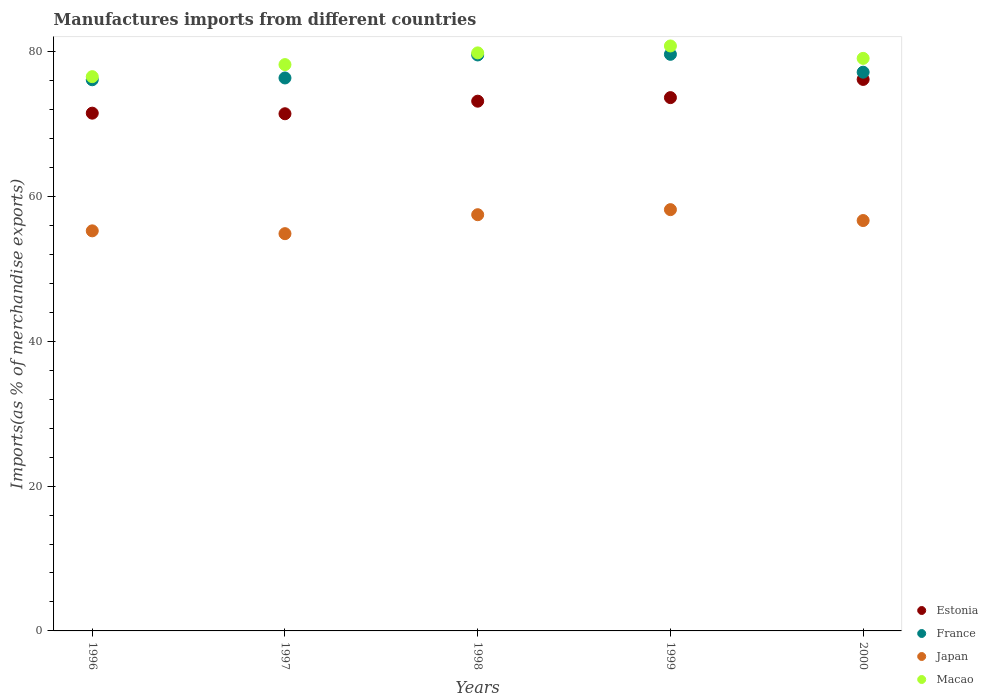Is the number of dotlines equal to the number of legend labels?
Provide a short and direct response. Yes. What is the percentage of imports to different countries in Macao in 1998?
Ensure brevity in your answer.  79.84. Across all years, what is the maximum percentage of imports to different countries in Japan?
Make the answer very short. 58.18. Across all years, what is the minimum percentage of imports to different countries in France?
Your response must be concise. 76.12. What is the total percentage of imports to different countries in Macao in the graph?
Provide a succinct answer. 394.47. What is the difference between the percentage of imports to different countries in France in 1996 and that in 2000?
Provide a short and direct response. -1.05. What is the difference between the percentage of imports to different countries in Japan in 1997 and the percentage of imports to different countries in Estonia in 1996?
Ensure brevity in your answer.  -16.64. What is the average percentage of imports to different countries in Macao per year?
Offer a very short reply. 78.89. In the year 1996, what is the difference between the percentage of imports to different countries in Macao and percentage of imports to different countries in France?
Ensure brevity in your answer.  0.43. What is the ratio of the percentage of imports to different countries in Japan in 1998 to that in 2000?
Make the answer very short. 1.01. What is the difference between the highest and the second highest percentage of imports to different countries in France?
Make the answer very short. 0.09. What is the difference between the highest and the lowest percentage of imports to different countries in Japan?
Your answer should be compact. 3.32. Is it the case that in every year, the sum of the percentage of imports to different countries in Japan and percentage of imports to different countries in Estonia  is greater than the sum of percentage of imports to different countries in France and percentage of imports to different countries in Macao?
Ensure brevity in your answer.  No. Does the percentage of imports to different countries in Japan monotonically increase over the years?
Provide a succinct answer. No. Is the percentage of imports to different countries in France strictly less than the percentage of imports to different countries in Estonia over the years?
Give a very brief answer. No. How many years are there in the graph?
Make the answer very short. 5. What is the difference between two consecutive major ticks on the Y-axis?
Make the answer very short. 20. Where does the legend appear in the graph?
Provide a succinct answer. Bottom right. How are the legend labels stacked?
Your answer should be compact. Vertical. What is the title of the graph?
Ensure brevity in your answer.  Manufactures imports from different countries. What is the label or title of the X-axis?
Give a very brief answer. Years. What is the label or title of the Y-axis?
Offer a very short reply. Imports(as % of merchandise exports). What is the Imports(as % of merchandise exports) in Estonia in 1996?
Give a very brief answer. 71.51. What is the Imports(as % of merchandise exports) of France in 1996?
Give a very brief answer. 76.12. What is the Imports(as % of merchandise exports) in Japan in 1996?
Keep it short and to the point. 55.26. What is the Imports(as % of merchandise exports) of Macao in 1996?
Keep it short and to the point. 76.55. What is the Imports(as % of merchandise exports) in Estonia in 1997?
Your response must be concise. 71.43. What is the Imports(as % of merchandise exports) in France in 1997?
Ensure brevity in your answer.  76.37. What is the Imports(as % of merchandise exports) in Japan in 1997?
Provide a short and direct response. 54.87. What is the Imports(as % of merchandise exports) of Macao in 1997?
Offer a very short reply. 78.22. What is the Imports(as % of merchandise exports) of Estonia in 1998?
Provide a short and direct response. 73.16. What is the Imports(as % of merchandise exports) of France in 1998?
Your response must be concise. 79.55. What is the Imports(as % of merchandise exports) in Japan in 1998?
Your answer should be very brief. 57.48. What is the Imports(as % of merchandise exports) of Macao in 1998?
Your answer should be compact. 79.84. What is the Imports(as % of merchandise exports) in Estonia in 1999?
Keep it short and to the point. 73.66. What is the Imports(as % of merchandise exports) in France in 1999?
Your answer should be compact. 79.64. What is the Imports(as % of merchandise exports) of Japan in 1999?
Make the answer very short. 58.18. What is the Imports(as % of merchandise exports) in Macao in 1999?
Provide a short and direct response. 80.79. What is the Imports(as % of merchandise exports) of Estonia in 2000?
Your answer should be very brief. 76.17. What is the Imports(as % of merchandise exports) of France in 2000?
Offer a terse response. 77.17. What is the Imports(as % of merchandise exports) in Japan in 2000?
Your response must be concise. 56.68. What is the Imports(as % of merchandise exports) in Macao in 2000?
Your answer should be compact. 79.08. Across all years, what is the maximum Imports(as % of merchandise exports) in Estonia?
Offer a very short reply. 76.17. Across all years, what is the maximum Imports(as % of merchandise exports) in France?
Keep it short and to the point. 79.64. Across all years, what is the maximum Imports(as % of merchandise exports) in Japan?
Your answer should be compact. 58.18. Across all years, what is the maximum Imports(as % of merchandise exports) in Macao?
Make the answer very short. 80.79. Across all years, what is the minimum Imports(as % of merchandise exports) in Estonia?
Your response must be concise. 71.43. Across all years, what is the minimum Imports(as % of merchandise exports) in France?
Keep it short and to the point. 76.12. Across all years, what is the minimum Imports(as % of merchandise exports) of Japan?
Make the answer very short. 54.87. Across all years, what is the minimum Imports(as % of merchandise exports) in Macao?
Your answer should be compact. 76.55. What is the total Imports(as % of merchandise exports) in Estonia in the graph?
Your answer should be compact. 365.93. What is the total Imports(as % of merchandise exports) of France in the graph?
Give a very brief answer. 388.85. What is the total Imports(as % of merchandise exports) in Japan in the graph?
Provide a short and direct response. 282.47. What is the total Imports(as % of merchandise exports) of Macao in the graph?
Provide a succinct answer. 394.47. What is the difference between the Imports(as % of merchandise exports) in Estonia in 1996 and that in 1997?
Provide a succinct answer. 0.08. What is the difference between the Imports(as % of merchandise exports) in France in 1996 and that in 1997?
Make the answer very short. -0.25. What is the difference between the Imports(as % of merchandise exports) in Japan in 1996 and that in 1997?
Give a very brief answer. 0.39. What is the difference between the Imports(as % of merchandise exports) of Macao in 1996 and that in 1997?
Your answer should be compact. -1.66. What is the difference between the Imports(as % of merchandise exports) of Estonia in 1996 and that in 1998?
Ensure brevity in your answer.  -1.66. What is the difference between the Imports(as % of merchandise exports) of France in 1996 and that in 1998?
Your response must be concise. -3.43. What is the difference between the Imports(as % of merchandise exports) in Japan in 1996 and that in 1998?
Ensure brevity in your answer.  -2.23. What is the difference between the Imports(as % of merchandise exports) of Macao in 1996 and that in 1998?
Give a very brief answer. -3.28. What is the difference between the Imports(as % of merchandise exports) in Estonia in 1996 and that in 1999?
Your answer should be very brief. -2.15. What is the difference between the Imports(as % of merchandise exports) in France in 1996 and that in 1999?
Offer a very short reply. -3.51. What is the difference between the Imports(as % of merchandise exports) in Japan in 1996 and that in 1999?
Offer a very short reply. -2.93. What is the difference between the Imports(as % of merchandise exports) in Macao in 1996 and that in 1999?
Give a very brief answer. -4.24. What is the difference between the Imports(as % of merchandise exports) of Estonia in 1996 and that in 2000?
Your answer should be very brief. -4.66. What is the difference between the Imports(as % of merchandise exports) of France in 1996 and that in 2000?
Your answer should be compact. -1.05. What is the difference between the Imports(as % of merchandise exports) of Japan in 1996 and that in 2000?
Keep it short and to the point. -1.42. What is the difference between the Imports(as % of merchandise exports) in Macao in 1996 and that in 2000?
Offer a terse response. -2.53. What is the difference between the Imports(as % of merchandise exports) of Estonia in 1997 and that in 1998?
Your response must be concise. -1.74. What is the difference between the Imports(as % of merchandise exports) in France in 1997 and that in 1998?
Provide a succinct answer. -3.18. What is the difference between the Imports(as % of merchandise exports) of Japan in 1997 and that in 1998?
Offer a very short reply. -2.62. What is the difference between the Imports(as % of merchandise exports) of Macao in 1997 and that in 1998?
Provide a short and direct response. -1.62. What is the difference between the Imports(as % of merchandise exports) of Estonia in 1997 and that in 1999?
Offer a very short reply. -2.23. What is the difference between the Imports(as % of merchandise exports) in France in 1997 and that in 1999?
Give a very brief answer. -3.27. What is the difference between the Imports(as % of merchandise exports) in Japan in 1997 and that in 1999?
Keep it short and to the point. -3.32. What is the difference between the Imports(as % of merchandise exports) of Macao in 1997 and that in 1999?
Your answer should be very brief. -2.58. What is the difference between the Imports(as % of merchandise exports) in Estonia in 1997 and that in 2000?
Offer a terse response. -4.74. What is the difference between the Imports(as % of merchandise exports) of France in 1997 and that in 2000?
Provide a succinct answer. -0.8. What is the difference between the Imports(as % of merchandise exports) of Japan in 1997 and that in 2000?
Your response must be concise. -1.81. What is the difference between the Imports(as % of merchandise exports) in Macao in 1997 and that in 2000?
Make the answer very short. -0.86. What is the difference between the Imports(as % of merchandise exports) in Estonia in 1998 and that in 1999?
Your answer should be compact. -0.49. What is the difference between the Imports(as % of merchandise exports) in France in 1998 and that in 1999?
Make the answer very short. -0.09. What is the difference between the Imports(as % of merchandise exports) of Japan in 1998 and that in 1999?
Offer a very short reply. -0.7. What is the difference between the Imports(as % of merchandise exports) in Macao in 1998 and that in 1999?
Your answer should be very brief. -0.96. What is the difference between the Imports(as % of merchandise exports) of Estonia in 1998 and that in 2000?
Your response must be concise. -3. What is the difference between the Imports(as % of merchandise exports) of France in 1998 and that in 2000?
Ensure brevity in your answer.  2.38. What is the difference between the Imports(as % of merchandise exports) of Japan in 1998 and that in 2000?
Make the answer very short. 0.8. What is the difference between the Imports(as % of merchandise exports) in Macao in 1998 and that in 2000?
Ensure brevity in your answer.  0.76. What is the difference between the Imports(as % of merchandise exports) in Estonia in 1999 and that in 2000?
Give a very brief answer. -2.51. What is the difference between the Imports(as % of merchandise exports) of France in 1999 and that in 2000?
Your response must be concise. 2.47. What is the difference between the Imports(as % of merchandise exports) of Japan in 1999 and that in 2000?
Offer a terse response. 1.5. What is the difference between the Imports(as % of merchandise exports) of Macao in 1999 and that in 2000?
Keep it short and to the point. 1.71. What is the difference between the Imports(as % of merchandise exports) in Estonia in 1996 and the Imports(as % of merchandise exports) in France in 1997?
Ensure brevity in your answer.  -4.86. What is the difference between the Imports(as % of merchandise exports) in Estonia in 1996 and the Imports(as % of merchandise exports) in Japan in 1997?
Your response must be concise. 16.64. What is the difference between the Imports(as % of merchandise exports) in Estonia in 1996 and the Imports(as % of merchandise exports) in Macao in 1997?
Keep it short and to the point. -6.71. What is the difference between the Imports(as % of merchandise exports) of France in 1996 and the Imports(as % of merchandise exports) of Japan in 1997?
Offer a very short reply. 21.26. What is the difference between the Imports(as % of merchandise exports) in France in 1996 and the Imports(as % of merchandise exports) in Macao in 1997?
Ensure brevity in your answer.  -2.09. What is the difference between the Imports(as % of merchandise exports) of Japan in 1996 and the Imports(as % of merchandise exports) of Macao in 1997?
Keep it short and to the point. -22.96. What is the difference between the Imports(as % of merchandise exports) in Estonia in 1996 and the Imports(as % of merchandise exports) in France in 1998?
Offer a terse response. -8.04. What is the difference between the Imports(as % of merchandise exports) in Estonia in 1996 and the Imports(as % of merchandise exports) in Japan in 1998?
Give a very brief answer. 14.02. What is the difference between the Imports(as % of merchandise exports) in Estonia in 1996 and the Imports(as % of merchandise exports) in Macao in 1998?
Give a very brief answer. -8.33. What is the difference between the Imports(as % of merchandise exports) in France in 1996 and the Imports(as % of merchandise exports) in Japan in 1998?
Keep it short and to the point. 18.64. What is the difference between the Imports(as % of merchandise exports) of France in 1996 and the Imports(as % of merchandise exports) of Macao in 1998?
Provide a succinct answer. -3.71. What is the difference between the Imports(as % of merchandise exports) of Japan in 1996 and the Imports(as % of merchandise exports) of Macao in 1998?
Offer a terse response. -24.58. What is the difference between the Imports(as % of merchandise exports) in Estonia in 1996 and the Imports(as % of merchandise exports) in France in 1999?
Keep it short and to the point. -8.13. What is the difference between the Imports(as % of merchandise exports) in Estonia in 1996 and the Imports(as % of merchandise exports) in Japan in 1999?
Your answer should be compact. 13.33. What is the difference between the Imports(as % of merchandise exports) in Estonia in 1996 and the Imports(as % of merchandise exports) in Macao in 1999?
Make the answer very short. -9.28. What is the difference between the Imports(as % of merchandise exports) of France in 1996 and the Imports(as % of merchandise exports) of Japan in 1999?
Provide a succinct answer. 17.94. What is the difference between the Imports(as % of merchandise exports) of France in 1996 and the Imports(as % of merchandise exports) of Macao in 1999?
Keep it short and to the point. -4.67. What is the difference between the Imports(as % of merchandise exports) of Japan in 1996 and the Imports(as % of merchandise exports) of Macao in 1999?
Your response must be concise. -25.54. What is the difference between the Imports(as % of merchandise exports) in Estonia in 1996 and the Imports(as % of merchandise exports) in France in 2000?
Make the answer very short. -5.66. What is the difference between the Imports(as % of merchandise exports) in Estonia in 1996 and the Imports(as % of merchandise exports) in Japan in 2000?
Provide a succinct answer. 14.83. What is the difference between the Imports(as % of merchandise exports) of Estonia in 1996 and the Imports(as % of merchandise exports) of Macao in 2000?
Your answer should be compact. -7.57. What is the difference between the Imports(as % of merchandise exports) in France in 1996 and the Imports(as % of merchandise exports) in Japan in 2000?
Offer a terse response. 19.44. What is the difference between the Imports(as % of merchandise exports) of France in 1996 and the Imports(as % of merchandise exports) of Macao in 2000?
Make the answer very short. -2.95. What is the difference between the Imports(as % of merchandise exports) of Japan in 1996 and the Imports(as % of merchandise exports) of Macao in 2000?
Your answer should be compact. -23.82. What is the difference between the Imports(as % of merchandise exports) of Estonia in 1997 and the Imports(as % of merchandise exports) of France in 1998?
Ensure brevity in your answer.  -8.12. What is the difference between the Imports(as % of merchandise exports) of Estonia in 1997 and the Imports(as % of merchandise exports) of Japan in 1998?
Provide a succinct answer. 13.94. What is the difference between the Imports(as % of merchandise exports) of Estonia in 1997 and the Imports(as % of merchandise exports) of Macao in 1998?
Offer a terse response. -8.41. What is the difference between the Imports(as % of merchandise exports) in France in 1997 and the Imports(as % of merchandise exports) in Japan in 1998?
Keep it short and to the point. 18.89. What is the difference between the Imports(as % of merchandise exports) of France in 1997 and the Imports(as % of merchandise exports) of Macao in 1998?
Your answer should be very brief. -3.47. What is the difference between the Imports(as % of merchandise exports) of Japan in 1997 and the Imports(as % of merchandise exports) of Macao in 1998?
Make the answer very short. -24.97. What is the difference between the Imports(as % of merchandise exports) of Estonia in 1997 and the Imports(as % of merchandise exports) of France in 1999?
Provide a succinct answer. -8.21. What is the difference between the Imports(as % of merchandise exports) of Estonia in 1997 and the Imports(as % of merchandise exports) of Japan in 1999?
Make the answer very short. 13.24. What is the difference between the Imports(as % of merchandise exports) of Estonia in 1997 and the Imports(as % of merchandise exports) of Macao in 1999?
Provide a short and direct response. -9.36. What is the difference between the Imports(as % of merchandise exports) in France in 1997 and the Imports(as % of merchandise exports) in Japan in 1999?
Your answer should be very brief. 18.19. What is the difference between the Imports(as % of merchandise exports) in France in 1997 and the Imports(as % of merchandise exports) in Macao in 1999?
Give a very brief answer. -4.42. What is the difference between the Imports(as % of merchandise exports) in Japan in 1997 and the Imports(as % of merchandise exports) in Macao in 1999?
Your answer should be compact. -25.92. What is the difference between the Imports(as % of merchandise exports) of Estonia in 1997 and the Imports(as % of merchandise exports) of France in 2000?
Give a very brief answer. -5.74. What is the difference between the Imports(as % of merchandise exports) in Estonia in 1997 and the Imports(as % of merchandise exports) in Japan in 2000?
Give a very brief answer. 14.75. What is the difference between the Imports(as % of merchandise exports) of Estonia in 1997 and the Imports(as % of merchandise exports) of Macao in 2000?
Make the answer very short. -7.65. What is the difference between the Imports(as % of merchandise exports) of France in 1997 and the Imports(as % of merchandise exports) of Japan in 2000?
Ensure brevity in your answer.  19.69. What is the difference between the Imports(as % of merchandise exports) of France in 1997 and the Imports(as % of merchandise exports) of Macao in 2000?
Ensure brevity in your answer.  -2.71. What is the difference between the Imports(as % of merchandise exports) of Japan in 1997 and the Imports(as % of merchandise exports) of Macao in 2000?
Give a very brief answer. -24.21. What is the difference between the Imports(as % of merchandise exports) of Estonia in 1998 and the Imports(as % of merchandise exports) of France in 1999?
Your response must be concise. -6.47. What is the difference between the Imports(as % of merchandise exports) of Estonia in 1998 and the Imports(as % of merchandise exports) of Japan in 1999?
Provide a short and direct response. 14.98. What is the difference between the Imports(as % of merchandise exports) in Estonia in 1998 and the Imports(as % of merchandise exports) in Macao in 1999?
Offer a terse response. -7.63. What is the difference between the Imports(as % of merchandise exports) of France in 1998 and the Imports(as % of merchandise exports) of Japan in 1999?
Offer a very short reply. 21.36. What is the difference between the Imports(as % of merchandise exports) in France in 1998 and the Imports(as % of merchandise exports) in Macao in 1999?
Provide a succinct answer. -1.24. What is the difference between the Imports(as % of merchandise exports) of Japan in 1998 and the Imports(as % of merchandise exports) of Macao in 1999?
Ensure brevity in your answer.  -23.31. What is the difference between the Imports(as % of merchandise exports) of Estonia in 1998 and the Imports(as % of merchandise exports) of France in 2000?
Offer a very short reply. -4. What is the difference between the Imports(as % of merchandise exports) of Estonia in 1998 and the Imports(as % of merchandise exports) of Japan in 2000?
Keep it short and to the point. 16.49. What is the difference between the Imports(as % of merchandise exports) in Estonia in 1998 and the Imports(as % of merchandise exports) in Macao in 2000?
Make the answer very short. -5.91. What is the difference between the Imports(as % of merchandise exports) in France in 1998 and the Imports(as % of merchandise exports) in Japan in 2000?
Offer a terse response. 22.87. What is the difference between the Imports(as % of merchandise exports) of France in 1998 and the Imports(as % of merchandise exports) of Macao in 2000?
Your answer should be very brief. 0.47. What is the difference between the Imports(as % of merchandise exports) in Japan in 1998 and the Imports(as % of merchandise exports) in Macao in 2000?
Your response must be concise. -21.59. What is the difference between the Imports(as % of merchandise exports) of Estonia in 1999 and the Imports(as % of merchandise exports) of France in 2000?
Keep it short and to the point. -3.51. What is the difference between the Imports(as % of merchandise exports) in Estonia in 1999 and the Imports(as % of merchandise exports) in Japan in 2000?
Provide a short and direct response. 16.98. What is the difference between the Imports(as % of merchandise exports) in Estonia in 1999 and the Imports(as % of merchandise exports) in Macao in 2000?
Your response must be concise. -5.42. What is the difference between the Imports(as % of merchandise exports) of France in 1999 and the Imports(as % of merchandise exports) of Japan in 2000?
Offer a terse response. 22.96. What is the difference between the Imports(as % of merchandise exports) in France in 1999 and the Imports(as % of merchandise exports) in Macao in 2000?
Offer a very short reply. 0.56. What is the difference between the Imports(as % of merchandise exports) in Japan in 1999 and the Imports(as % of merchandise exports) in Macao in 2000?
Offer a very short reply. -20.89. What is the average Imports(as % of merchandise exports) of Estonia per year?
Your answer should be very brief. 73.19. What is the average Imports(as % of merchandise exports) of France per year?
Make the answer very short. 77.77. What is the average Imports(as % of merchandise exports) of Japan per year?
Ensure brevity in your answer.  56.49. What is the average Imports(as % of merchandise exports) in Macao per year?
Your answer should be very brief. 78.89. In the year 1996, what is the difference between the Imports(as % of merchandise exports) of Estonia and Imports(as % of merchandise exports) of France?
Ensure brevity in your answer.  -4.61. In the year 1996, what is the difference between the Imports(as % of merchandise exports) of Estonia and Imports(as % of merchandise exports) of Japan?
Ensure brevity in your answer.  16.25. In the year 1996, what is the difference between the Imports(as % of merchandise exports) of Estonia and Imports(as % of merchandise exports) of Macao?
Your answer should be compact. -5.04. In the year 1996, what is the difference between the Imports(as % of merchandise exports) of France and Imports(as % of merchandise exports) of Japan?
Provide a succinct answer. 20.87. In the year 1996, what is the difference between the Imports(as % of merchandise exports) in France and Imports(as % of merchandise exports) in Macao?
Offer a terse response. -0.43. In the year 1996, what is the difference between the Imports(as % of merchandise exports) of Japan and Imports(as % of merchandise exports) of Macao?
Your answer should be very brief. -21.3. In the year 1997, what is the difference between the Imports(as % of merchandise exports) of Estonia and Imports(as % of merchandise exports) of France?
Provide a succinct answer. -4.94. In the year 1997, what is the difference between the Imports(as % of merchandise exports) in Estonia and Imports(as % of merchandise exports) in Japan?
Your answer should be compact. 16.56. In the year 1997, what is the difference between the Imports(as % of merchandise exports) of Estonia and Imports(as % of merchandise exports) of Macao?
Your response must be concise. -6.79. In the year 1997, what is the difference between the Imports(as % of merchandise exports) of France and Imports(as % of merchandise exports) of Japan?
Your answer should be very brief. 21.5. In the year 1997, what is the difference between the Imports(as % of merchandise exports) in France and Imports(as % of merchandise exports) in Macao?
Your answer should be compact. -1.85. In the year 1997, what is the difference between the Imports(as % of merchandise exports) of Japan and Imports(as % of merchandise exports) of Macao?
Ensure brevity in your answer.  -23.35. In the year 1998, what is the difference between the Imports(as % of merchandise exports) in Estonia and Imports(as % of merchandise exports) in France?
Your answer should be very brief. -6.38. In the year 1998, what is the difference between the Imports(as % of merchandise exports) in Estonia and Imports(as % of merchandise exports) in Japan?
Keep it short and to the point. 15.68. In the year 1998, what is the difference between the Imports(as % of merchandise exports) of Estonia and Imports(as % of merchandise exports) of Macao?
Ensure brevity in your answer.  -6.67. In the year 1998, what is the difference between the Imports(as % of merchandise exports) of France and Imports(as % of merchandise exports) of Japan?
Your answer should be very brief. 22.06. In the year 1998, what is the difference between the Imports(as % of merchandise exports) in France and Imports(as % of merchandise exports) in Macao?
Your answer should be very brief. -0.29. In the year 1998, what is the difference between the Imports(as % of merchandise exports) of Japan and Imports(as % of merchandise exports) of Macao?
Offer a terse response. -22.35. In the year 1999, what is the difference between the Imports(as % of merchandise exports) of Estonia and Imports(as % of merchandise exports) of France?
Make the answer very short. -5.98. In the year 1999, what is the difference between the Imports(as % of merchandise exports) of Estonia and Imports(as % of merchandise exports) of Japan?
Keep it short and to the point. 15.47. In the year 1999, what is the difference between the Imports(as % of merchandise exports) in Estonia and Imports(as % of merchandise exports) in Macao?
Offer a terse response. -7.14. In the year 1999, what is the difference between the Imports(as % of merchandise exports) in France and Imports(as % of merchandise exports) in Japan?
Your answer should be very brief. 21.45. In the year 1999, what is the difference between the Imports(as % of merchandise exports) in France and Imports(as % of merchandise exports) in Macao?
Your answer should be very brief. -1.15. In the year 1999, what is the difference between the Imports(as % of merchandise exports) of Japan and Imports(as % of merchandise exports) of Macao?
Your answer should be very brief. -22.61. In the year 2000, what is the difference between the Imports(as % of merchandise exports) in Estonia and Imports(as % of merchandise exports) in France?
Ensure brevity in your answer.  -1. In the year 2000, what is the difference between the Imports(as % of merchandise exports) in Estonia and Imports(as % of merchandise exports) in Japan?
Your answer should be compact. 19.49. In the year 2000, what is the difference between the Imports(as % of merchandise exports) in Estonia and Imports(as % of merchandise exports) in Macao?
Your answer should be very brief. -2.91. In the year 2000, what is the difference between the Imports(as % of merchandise exports) of France and Imports(as % of merchandise exports) of Japan?
Make the answer very short. 20.49. In the year 2000, what is the difference between the Imports(as % of merchandise exports) in France and Imports(as % of merchandise exports) in Macao?
Your answer should be compact. -1.91. In the year 2000, what is the difference between the Imports(as % of merchandise exports) in Japan and Imports(as % of merchandise exports) in Macao?
Your answer should be very brief. -22.4. What is the ratio of the Imports(as % of merchandise exports) in France in 1996 to that in 1997?
Give a very brief answer. 1. What is the ratio of the Imports(as % of merchandise exports) in Japan in 1996 to that in 1997?
Your response must be concise. 1.01. What is the ratio of the Imports(as % of merchandise exports) of Macao in 1996 to that in 1997?
Provide a succinct answer. 0.98. What is the ratio of the Imports(as % of merchandise exports) of Estonia in 1996 to that in 1998?
Offer a very short reply. 0.98. What is the ratio of the Imports(as % of merchandise exports) of France in 1996 to that in 1998?
Provide a succinct answer. 0.96. What is the ratio of the Imports(as % of merchandise exports) of Japan in 1996 to that in 1998?
Your answer should be very brief. 0.96. What is the ratio of the Imports(as % of merchandise exports) of Macao in 1996 to that in 1998?
Your answer should be compact. 0.96. What is the ratio of the Imports(as % of merchandise exports) of Estonia in 1996 to that in 1999?
Your answer should be compact. 0.97. What is the ratio of the Imports(as % of merchandise exports) in France in 1996 to that in 1999?
Provide a succinct answer. 0.96. What is the ratio of the Imports(as % of merchandise exports) of Japan in 1996 to that in 1999?
Your answer should be very brief. 0.95. What is the ratio of the Imports(as % of merchandise exports) in Macao in 1996 to that in 1999?
Keep it short and to the point. 0.95. What is the ratio of the Imports(as % of merchandise exports) of Estonia in 1996 to that in 2000?
Make the answer very short. 0.94. What is the ratio of the Imports(as % of merchandise exports) in France in 1996 to that in 2000?
Ensure brevity in your answer.  0.99. What is the ratio of the Imports(as % of merchandise exports) in Japan in 1996 to that in 2000?
Your answer should be compact. 0.97. What is the ratio of the Imports(as % of merchandise exports) of Macao in 1996 to that in 2000?
Offer a very short reply. 0.97. What is the ratio of the Imports(as % of merchandise exports) of Estonia in 1997 to that in 1998?
Your response must be concise. 0.98. What is the ratio of the Imports(as % of merchandise exports) in Japan in 1997 to that in 1998?
Your answer should be compact. 0.95. What is the ratio of the Imports(as % of merchandise exports) in Macao in 1997 to that in 1998?
Your answer should be compact. 0.98. What is the ratio of the Imports(as % of merchandise exports) in Estonia in 1997 to that in 1999?
Give a very brief answer. 0.97. What is the ratio of the Imports(as % of merchandise exports) in France in 1997 to that in 1999?
Give a very brief answer. 0.96. What is the ratio of the Imports(as % of merchandise exports) in Japan in 1997 to that in 1999?
Provide a succinct answer. 0.94. What is the ratio of the Imports(as % of merchandise exports) in Macao in 1997 to that in 1999?
Your answer should be very brief. 0.97. What is the ratio of the Imports(as % of merchandise exports) of Estonia in 1997 to that in 2000?
Offer a very short reply. 0.94. What is the ratio of the Imports(as % of merchandise exports) of France in 1997 to that in 2000?
Your response must be concise. 0.99. What is the ratio of the Imports(as % of merchandise exports) in France in 1998 to that in 1999?
Your response must be concise. 1. What is the ratio of the Imports(as % of merchandise exports) of Japan in 1998 to that in 1999?
Your response must be concise. 0.99. What is the ratio of the Imports(as % of merchandise exports) in Macao in 1998 to that in 1999?
Your answer should be very brief. 0.99. What is the ratio of the Imports(as % of merchandise exports) of Estonia in 1998 to that in 2000?
Your response must be concise. 0.96. What is the ratio of the Imports(as % of merchandise exports) in France in 1998 to that in 2000?
Provide a short and direct response. 1.03. What is the ratio of the Imports(as % of merchandise exports) in Japan in 1998 to that in 2000?
Provide a short and direct response. 1.01. What is the ratio of the Imports(as % of merchandise exports) of Macao in 1998 to that in 2000?
Offer a terse response. 1.01. What is the ratio of the Imports(as % of merchandise exports) in Estonia in 1999 to that in 2000?
Provide a short and direct response. 0.97. What is the ratio of the Imports(as % of merchandise exports) in France in 1999 to that in 2000?
Offer a terse response. 1.03. What is the ratio of the Imports(as % of merchandise exports) in Japan in 1999 to that in 2000?
Provide a succinct answer. 1.03. What is the ratio of the Imports(as % of merchandise exports) of Macao in 1999 to that in 2000?
Offer a terse response. 1.02. What is the difference between the highest and the second highest Imports(as % of merchandise exports) in Estonia?
Offer a terse response. 2.51. What is the difference between the highest and the second highest Imports(as % of merchandise exports) in France?
Offer a terse response. 0.09. What is the difference between the highest and the second highest Imports(as % of merchandise exports) of Japan?
Give a very brief answer. 0.7. What is the difference between the highest and the second highest Imports(as % of merchandise exports) of Macao?
Your answer should be compact. 0.96. What is the difference between the highest and the lowest Imports(as % of merchandise exports) in Estonia?
Keep it short and to the point. 4.74. What is the difference between the highest and the lowest Imports(as % of merchandise exports) in France?
Give a very brief answer. 3.51. What is the difference between the highest and the lowest Imports(as % of merchandise exports) of Japan?
Provide a succinct answer. 3.32. What is the difference between the highest and the lowest Imports(as % of merchandise exports) of Macao?
Ensure brevity in your answer.  4.24. 